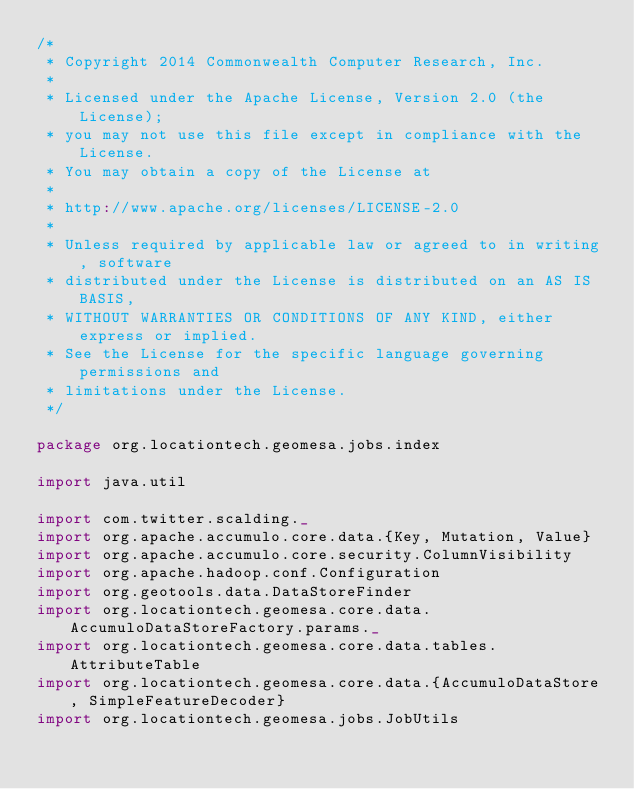<code> <loc_0><loc_0><loc_500><loc_500><_Scala_>/*
 * Copyright 2014 Commonwealth Computer Research, Inc.
 *
 * Licensed under the Apache License, Version 2.0 (the License);
 * you may not use this file except in compliance with the License.
 * You may obtain a copy of the License at
 *
 * http://www.apache.org/licenses/LICENSE-2.0
 *
 * Unless required by applicable law or agreed to in writing, software
 * distributed under the License is distributed on an AS IS BASIS,
 * WITHOUT WARRANTIES OR CONDITIONS OF ANY KIND, either express or implied.
 * See the License for the specific language governing permissions and
 * limitations under the License.
 */

package org.locationtech.geomesa.jobs.index

import java.util

import com.twitter.scalding._
import org.apache.accumulo.core.data.{Key, Mutation, Value}
import org.apache.accumulo.core.security.ColumnVisibility
import org.apache.hadoop.conf.Configuration
import org.geotools.data.DataStoreFinder
import org.locationtech.geomesa.core.data.AccumuloDataStoreFactory.params._
import org.locationtech.geomesa.core.data.tables.AttributeTable
import org.locationtech.geomesa.core.data.{AccumuloDataStore, SimpleFeatureDecoder}
import org.locationtech.geomesa.jobs.JobUtils</code> 